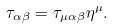Convert formula to latex. <formula><loc_0><loc_0><loc_500><loc_500>\tau _ { \alpha \beta } = \tau _ { \mu \alpha \beta } \eta ^ { \mu } .</formula> 